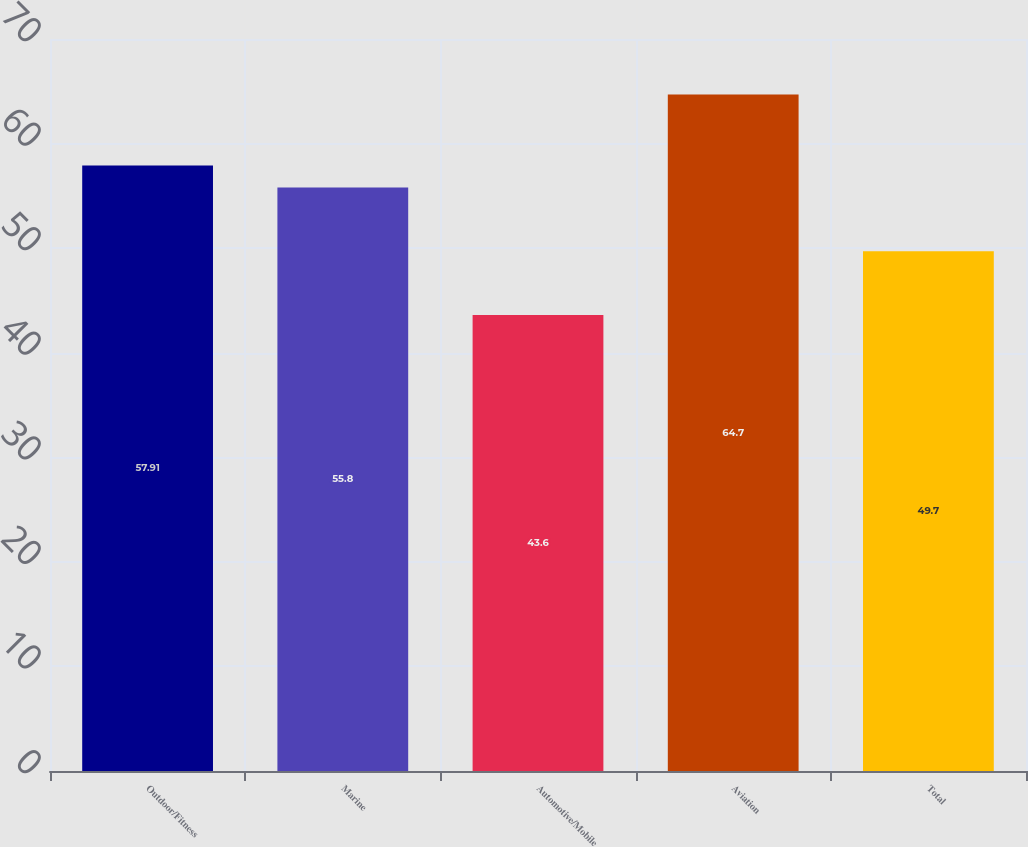<chart> <loc_0><loc_0><loc_500><loc_500><bar_chart><fcel>Outdoor/Fitness<fcel>Marine<fcel>Automotive/Mobile<fcel>Aviation<fcel>Total<nl><fcel>57.91<fcel>55.8<fcel>43.6<fcel>64.7<fcel>49.7<nl></chart> 